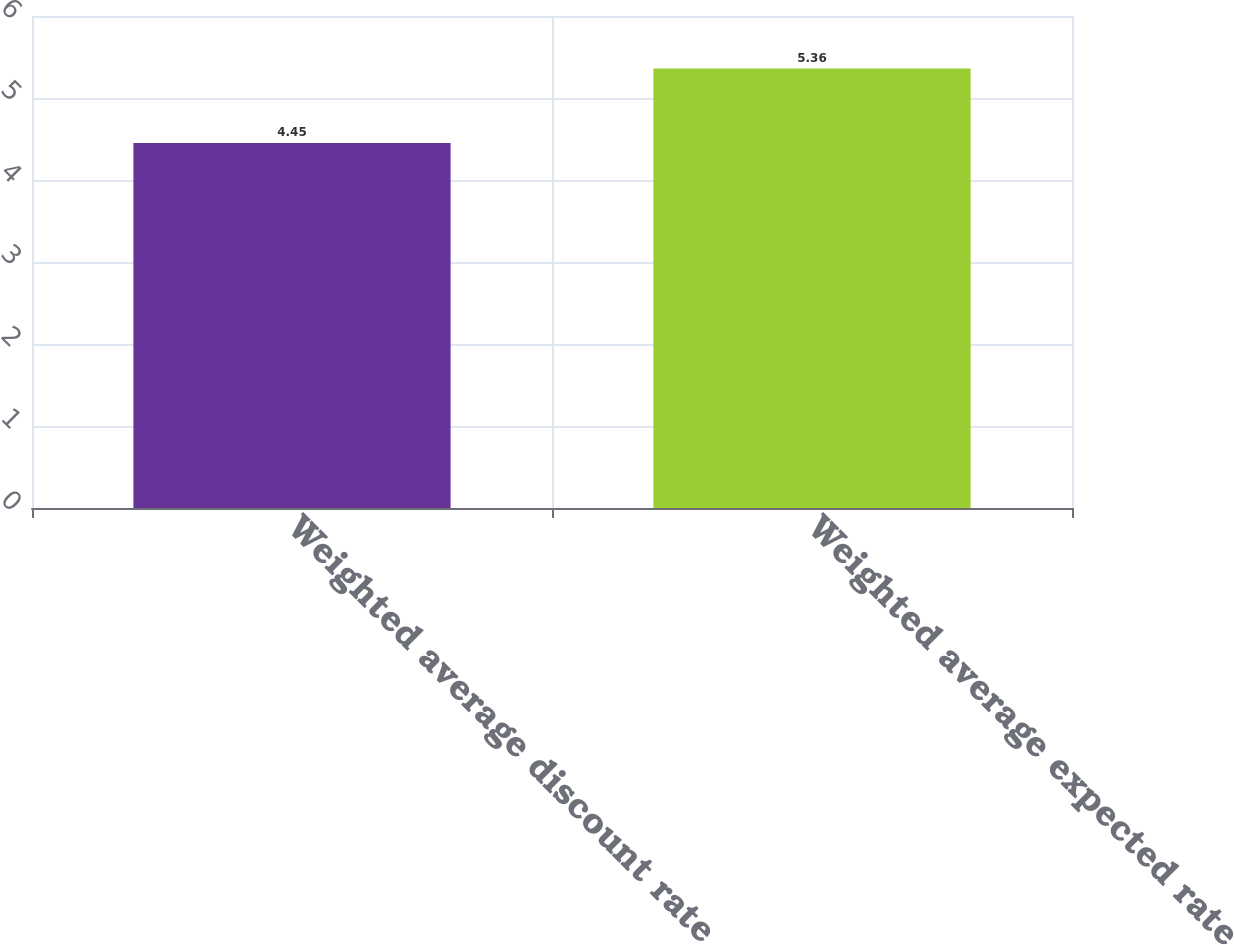<chart> <loc_0><loc_0><loc_500><loc_500><bar_chart><fcel>Weighted average discount rate<fcel>Weighted average expected rate<nl><fcel>4.45<fcel>5.36<nl></chart> 